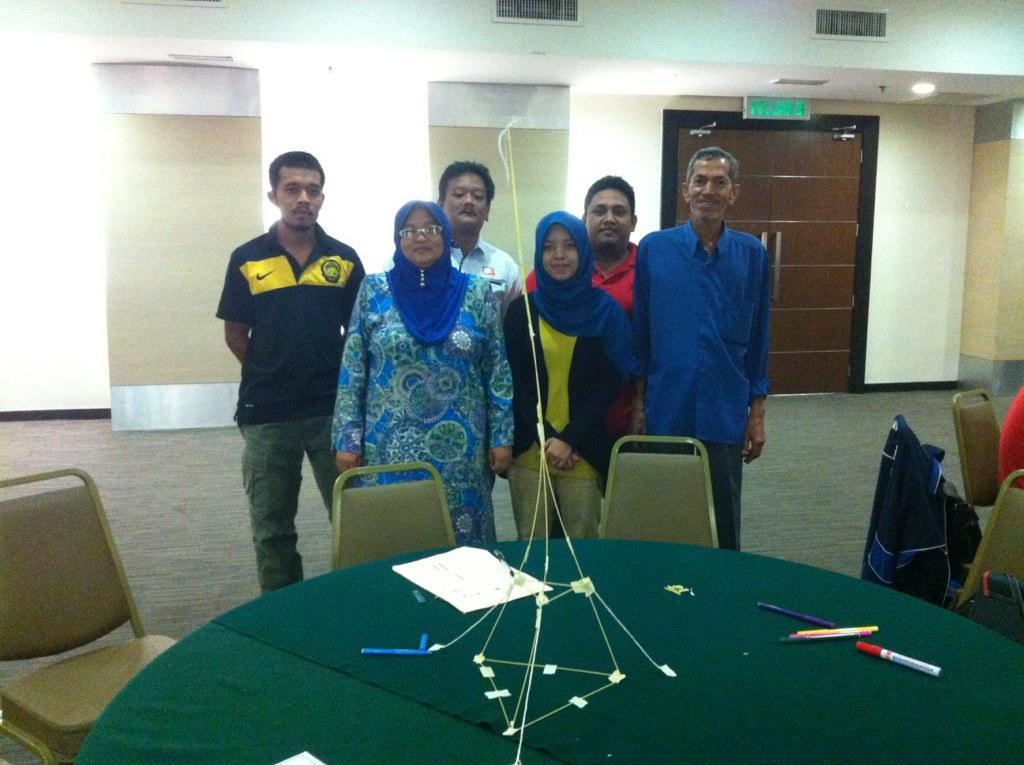Could you give a brief overview of what you see in this image? In this image I can see few chairs around the table which is green in color and on the table I can see few papers, few pens and few other objects. I can see few persons standing and in the background I can see the wall, few lights, the door and the green colored board. 